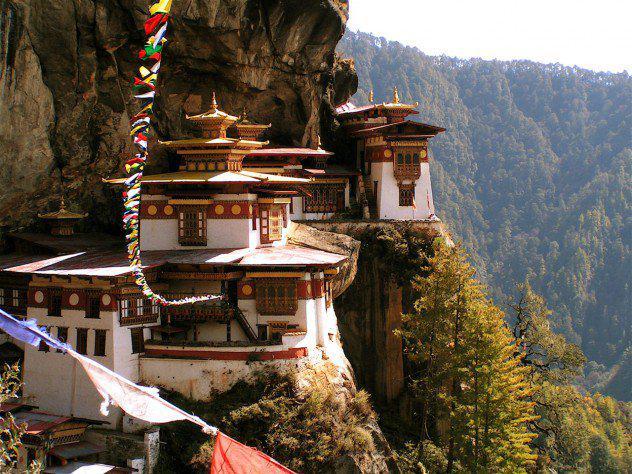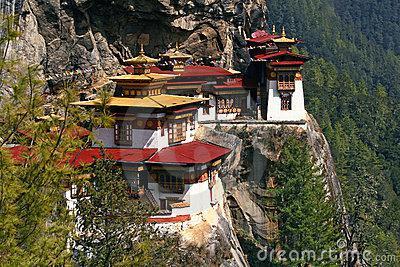The first image is the image on the left, the second image is the image on the right. For the images displayed, is the sentence "One photo shows one or more monks with yellow robes and an umbrella." factually correct? Answer yes or no. No. The first image is the image on the left, the second image is the image on the right. Evaluate the accuracy of this statement regarding the images: "There is at least one person dressed in a yellow robe carrying an umbrella". Is it true? Answer yes or no. No. 